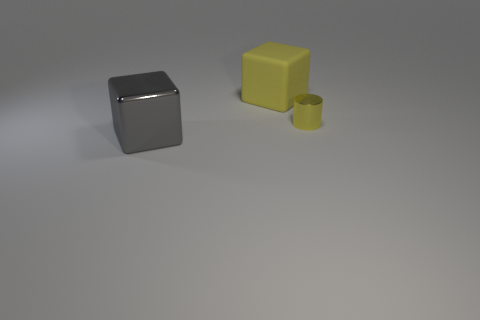What could be the possible size of these objects in relation to each other? From their appearance, the silver cube seems to be the largest, followed by the yellow block, and lastly, the small yellow cylinder, which appears to be the smallest. 